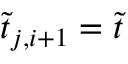<formula> <loc_0><loc_0><loc_500><loc_500>\tilde { t } _ { j , i + 1 } = \tilde { t }</formula> 